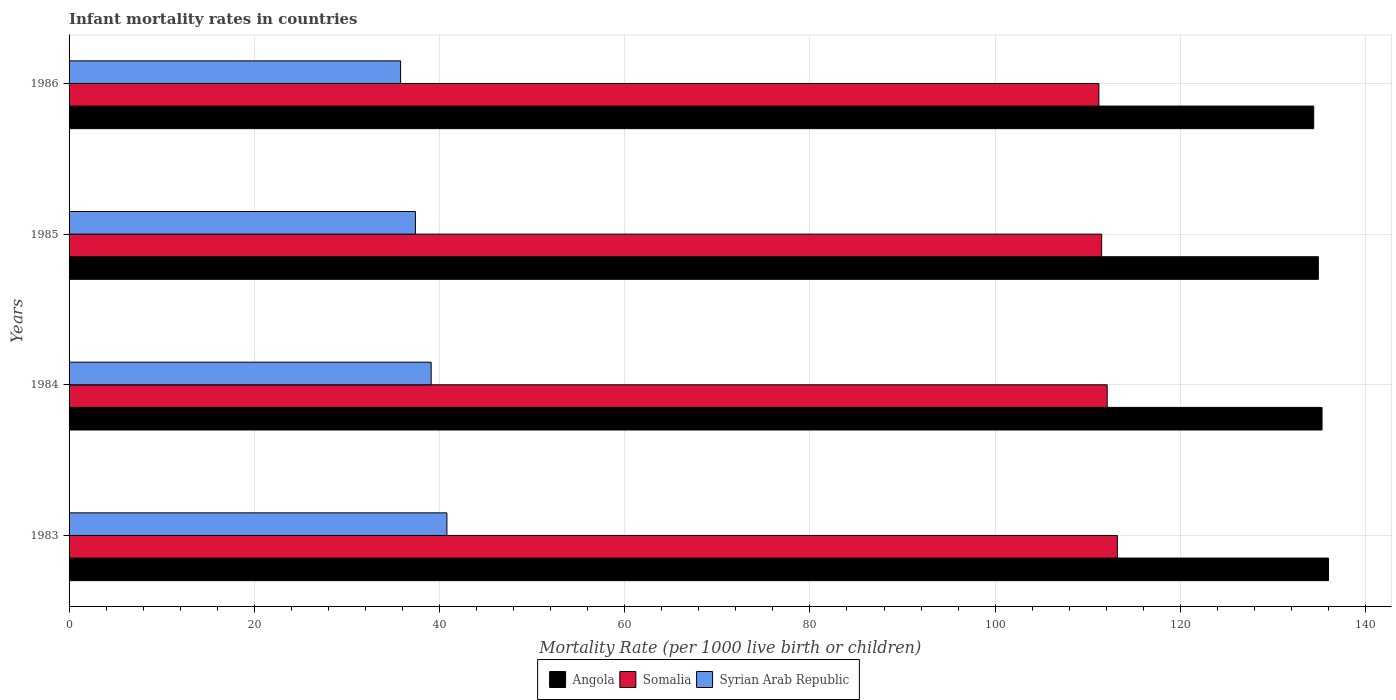How many different coloured bars are there?
Offer a terse response. 3. How many groups of bars are there?
Your answer should be very brief. 4. Are the number of bars per tick equal to the number of legend labels?
Keep it short and to the point. Yes. Are the number of bars on each tick of the Y-axis equal?
Give a very brief answer. Yes. How many bars are there on the 3rd tick from the bottom?
Ensure brevity in your answer.  3. What is the label of the 1st group of bars from the top?
Keep it short and to the point. 1986. In how many cases, is the number of bars for a given year not equal to the number of legend labels?
Provide a short and direct response. 0. What is the infant mortality rate in Syrian Arab Republic in 1986?
Your answer should be very brief. 35.8. Across all years, what is the maximum infant mortality rate in Angola?
Provide a short and direct response. 136. Across all years, what is the minimum infant mortality rate in Somalia?
Offer a very short reply. 111.2. In which year was the infant mortality rate in Somalia maximum?
Your response must be concise. 1983. In which year was the infant mortality rate in Syrian Arab Republic minimum?
Provide a short and direct response. 1986. What is the total infant mortality rate in Angola in the graph?
Provide a succinct answer. 540.6. What is the difference between the infant mortality rate in Somalia in 1983 and that in 1984?
Your answer should be very brief. 1.1. What is the difference between the infant mortality rate in Somalia in 1985 and the infant mortality rate in Syrian Arab Republic in 1983?
Make the answer very short. 70.7. What is the average infant mortality rate in Angola per year?
Offer a terse response. 135.15. In the year 1986, what is the difference between the infant mortality rate in Syrian Arab Republic and infant mortality rate in Somalia?
Ensure brevity in your answer.  -75.4. In how many years, is the infant mortality rate in Syrian Arab Republic greater than 92 ?
Make the answer very short. 0. What is the ratio of the infant mortality rate in Somalia in 1983 to that in 1986?
Your response must be concise. 1.02. Is the infant mortality rate in Somalia in 1983 less than that in 1985?
Offer a very short reply. No. Is the difference between the infant mortality rate in Syrian Arab Republic in 1983 and 1985 greater than the difference between the infant mortality rate in Somalia in 1983 and 1985?
Keep it short and to the point. Yes. What is the difference between the highest and the second highest infant mortality rate in Syrian Arab Republic?
Ensure brevity in your answer.  1.7. What is the difference between the highest and the lowest infant mortality rate in Somalia?
Ensure brevity in your answer.  2. Is the sum of the infant mortality rate in Angola in 1984 and 1986 greater than the maximum infant mortality rate in Syrian Arab Republic across all years?
Ensure brevity in your answer.  Yes. What does the 3rd bar from the top in 1986 represents?
Make the answer very short. Angola. What does the 3rd bar from the bottom in 1986 represents?
Provide a succinct answer. Syrian Arab Republic. How many bars are there?
Your response must be concise. 12. Are all the bars in the graph horizontal?
Ensure brevity in your answer.  Yes. Does the graph contain any zero values?
Your answer should be very brief. No. Does the graph contain grids?
Your response must be concise. Yes. How many legend labels are there?
Provide a succinct answer. 3. What is the title of the graph?
Provide a short and direct response. Infant mortality rates in countries. Does "Norway" appear as one of the legend labels in the graph?
Provide a succinct answer. No. What is the label or title of the X-axis?
Your response must be concise. Mortality Rate (per 1000 live birth or children). What is the Mortality Rate (per 1000 live birth or children) in Angola in 1983?
Provide a short and direct response. 136. What is the Mortality Rate (per 1000 live birth or children) in Somalia in 1983?
Offer a very short reply. 113.2. What is the Mortality Rate (per 1000 live birth or children) of Syrian Arab Republic in 1983?
Give a very brief answer. 40.8. What is the Mortality Rate (per 1000 live birth or children) of Angola in 1984?
Your answer should be compact. 135.3. What is the Mortality Rate (per 1000 live birth or children) of Somalia in 1984?
Ensure brevity in your answer.  112.1. What is the Mortality Rate (per 1000 live birth or children) of Syrian Arab Republic in 1984?
Provide a succinct answer. 39.1. What is the Mortality Rate (per 1000 live birth or children) of Angola in 1985?
Make the answer very short. 134.9. What is the Mortality Rate (per 1000 live birth or children) of Somalia in 1985?
Your response must be concise. 111.5. What is the Mortality Rate (per 1000 live birth or children) in Syrian Arab Republic in 1985?
Keep it short and to the point. 37.4. What is the Mortality Rate (per 1000 live birth or children) in Angola in 1986?
Your response must be concise. 134.4. What is the Mortality Rate (per 1000 live birth or children) in Somalia in 1986?
Provide a short and direct response. 111.2. What is the Mortality Rate (per 1000 live birth or children) in Syrian Arab Republic in 1986?
Offer a terse response. 35.8. Across all years, what is the maximum Mortality Rate (per 1000 live birth or children) in Angola?
Provide a short and direct response. 136. Across all years, what is the maximum Mortality Rate (per 1000 live birth or children) of Somalia?
Make the answer very short. 113.2. Across all years, what is the maximum Mortality Rate (per 1000 live birth or children) of Syrian Arab Republic?
Provide a succinct answer. 40.8. Across all years, what is the minimum Mortality Rate (per 1000 live birth or children) in Angola?
Your answer should be very brief. 134.4. Across all years, what is the minimum Mortality Rate (per 1000 live birth or children) in Somalia?
Your response must be concise. 111.2. Across all years, what is the minimum Mortality Rate (per 1000 live birth or children) in Syrian Arab Republic?
Offer a terse response. 35.8. What is the total Mortality Rate (per 1000 live birth or children) of Angola in the graph?
Your response must be concise. 540.6. What is the total Mortality Rate (per 1000 live birth or children) of Somalia in the graph?
Offer a very short reply. 448. What is the total Mortality Rate (per 1000 live birth or children) in Syrian Arab Republic in the graph?
Give a very brief answer. 153.1. What is the difference between the Mortality Rate (per 1000 live birth or children) in Somalia in 1983 and that in 1984?
Your answer should be very brief. 1.1. What is the difference between the Mortality Rate (per 1000 live birth or children) of Somalia in 1983 and that in 1985?
Provide a succinct answer. 1.7. What is the difference between the Mortality Rate (per 1000 live birth or children) of Angola in 1983 and that in 1986?
Provide a succinct answer. 1.6. What is the difference between the Mortality Rate (per 1000 live birth or children) in Somalia in 1983 and that in 1986?
Your answer should be compact. 2. What is the difference between the Mortality Rate (per 1000 live birth or children) of Syrian Arab Republic in 1983 and that in 1986?
Make the answer very short. 5. What is the difference between the Mortality Rate (per 1000 live birth or children) of Somalia in 1984 and that in 1986?
Offer a terse response. 0.9. What is the difference between the Mortality Rate (per 1000 live birth or children) of Syrian Arab Republic in 1984 and that in 1986?
Your response must be concise. 3.3. What is the difference between the Mortality Rate (per 1000 live birth or children) in Angola in 1985 and that in 1986?
Offer a terse response. 0.5. What is the difference between the Mortality Rate (per 1000 live birth or children) in Somalia in 1985 and that in 1986?
Keep it short and to the point. 0.3. What is the difference between the Mortality Rate (per 1000 live birth or children) in Angola in 1983 and the Mortality Rate (per 1000 live birth or children) in Somalia in 1984?
Provide a short and direct response. 23.9. What is the difference between the Mortality Rate (per 1000 live birth or children) in Angola in 1983 and the Mortality Rate (per 1000 live birth or children) in Syrian Arab Republic in 1984?
Your answer should be compact. 96.9. What is the difference between the Mortality Rate (per 1000 live birth or children) in Somalia in 1983 and the Mortality Rate (per 1000 live birth or children) in Syrian Arab Republic in 1984?
Your answer should be compact. 74.1. What is the difference between the Mortality Rate (per 1000 live birth or children) in Angola in 1983 and the Mortality Rate (per 1000 live birth or children) in Somalia in 1985?
Your answer should be very brief. 24.5. What is the difference between the Mortality Rate (per 1000 live birth or children) in Angola in 1983 and the Mortality Rate (per 1000 live birth or children) in Syrian Arab Republic in 1985?
Provide a short and direct response. 98.6. What is the difference between the Mortality Rate (per 1000 live birth or children) of Somalia in 1983 and the Mortality Rate (per 1000 live birth or children) of Syrian Arab Republic in 1985?
Offer a very short reply. 75.8. What is the difference between the Mortality Rate (per 1000 live birth or children) in Angola in 1983 and the Mortality Rate (per 1000 live birth or children) in Somalia in 1986?
Your answer should be very brief. 24.8. What is the difference between the Mortality Rate (per 1000 live birth or children) in Angola in 1983 and the Mortality Rate (per 1000 live birth or children) in Syrian Arab Republic in 1986?
Offer a terse response. 100.2. What is the difference between the Mortality Rate (per 1000 live birth or children) of Somalia in 1983 and the Mortality Rate (per 1000 live birth or children) of Syrian Arab Republic in 1986?
Give a very brief answer. 77.4. What is the difference between the Mortality Rate (per 1000 live birth or children) in Angola in 1984 and the Mortality Rate (per 1000 live birth or children) in Somalia in 1985?
Keep it short and to the point. 23.8. What is the difference between the Mortality Rate (per 1000 live birth or children) in Angola in 1984 and the Mortality Rate (per 1000 live birth or children) in Syrian Arab Republic in 1985?
Offer a very short reply. 97.9. What is the difference between the Mortality Rate (per 1000 live birth or children) in Somalia in 1984 and the Mortality Rate (per 1000 live birth or children) in Syrian Arab Republic in 1985?
Your answer should be compact. 74.7. What is the difference between the Mortality Rate (per 1000 live birth or children) of Angola in 1984 and the Mortality Rate (per 1000 live birth or children) of Somalia in 1986?
Your answer should be very brief. 24.1. What is the difference between the Mortality Rate (per 1000 live birth or children) of Angola in 1984 and the Mortality Rate (per 1000 live birth or children) of Syrian Arab Republic in 1986?
Give a very brief answer. 99.5. What is the difference between the Mortality Rate (per 1000 live birth or children) in Somalia in 1984 and the Mortality Rate (per 1000 live birth or children) in Syrian Arab Republic in 1986?
Give a very brief answer. 76.3. What is the difference between the Mortality Rate (per 1000 live birth or children) of Angola in 1985 and the Mortality Rate (per 1000 live birth or children) of Somalia in 1986?
Your answer should be compact. 23.7. What is the difference between the Mortality Rate (per 1000 live birth or children) of Angola in 1985 and the Mortality Rate (per 1000 live birth or children) of Syrian Arab Republic in 1986?
Offer a terse response. 99.1. What is the difference between the Mortality Rate (per 1000 live birth or children) in Somalia in 1985 and the Mortality Rate (per 1000 live birth or children) in Syrian Arab Republic in 1986?
Offer a very short reply. 75.7. What is the average Mortality Rate (per 1000 live birth or children) in Angola per year?
Your answer should be very brief. 135.15. What is the average Mortality Rate (per 1000 live birth or children) of Somalia per year?
Offer a very short reply. 112. What is the average Mortality Rate (per 1000 live birth or children) of Syrian Arab Republic per year?
Give a very brief answer. 38.27. In the year 1983, what is the difference between the Mortality Rate (per 1000 live birth or children) in Angola and Mortality Rate (per 1000 live birth or children) in Somalia?
Provide a short and direct response. 22.8. In the year 1983, what is the difference between the Mortality Rate (per 1000 live birth or children) in Angola and Mortality Rate (per 1000 live birth or children) in Syrian Arab Republic?
Your answer should be very brief. 95.2. In the year 1983, what is the difference between the Mortality Rate (per 1000 live birth or children) of Somalia and Mortality Rate (per 1000 live birth or children) of Syrian Arab Republic?
Ensure brevity in your answer.  72.4. In the year 1984, what is the difference between the Mortality Rate (per 1000 live birth or children) of Angola and Mortality Rate (per 1000 live birth or children) of Somalia?
Give a very brief answer. 23.2. In the year 1984, what is the difference between the Mortality Rate (per 1000 live birth or children) of Angola and Mortality Rate (per 1000 live birth or children) of Syrian Arab Republic?
Offer a very short reply. 96.2. In the year 1984, what is the difference between the Mortality Rate (per 1000 live birth or children) in Somalia and Mortality Rate (per 1000 live birth or children) in Syrian Arab Republic?
Provide a short and direct response. 73. In the year 1985, what is the difference between the Mortality Rate (per 1000 live birth or children) in Angola and Mortality Rate (per 1000 live birth or children) in Somalia?
Your answer should be very brief. 23.4. In the year 1985, what is the difference between the Mortality Rate (per 1000 live birth or children) in Angola and Mortality Rate (per 1000 live birth or children) in Syrian Arab Republic?
Provide a succinct answer. 97.5. In the year 1985, what is the difference between the Mortality Rate (per 1000 live birth or children) of Somalia and Mortality Rate (per 1000 live birth or children) of Syrian Arab Republic?
Offer a very short reply. 74.1. In the year 1986, what is the difference between the Mortality Rate (per 1000 live birth or children) of Angola and Mortality Rate (per 1000 live birth or children) of Somalia?
Your answer should be very brief. 23.2. In the year 1986, what is the difference between the Mortality Rate (per 1000 live birth or children) of Angola and Mortality Rate (per 1000 live birth or children) of Syrian Arab Republic?
Make the answer very short. 98.6. In the year 1986, what is the difference between the Mortality Rate (per 1000 live birth or children) in Somalia and Mortality Rate (per 1000 live birth or children) in Syrian Arab Republic?
Your response must be concise. 75.4. What is the ratio of the Mortality Rate (per 1000 live birth or children) of Somalia in 1983 to that in 1984?
Offer a terse response. 1.01. What is the ratio of the Mortality Rate (per 1000 live birth or children) of Syrian Arab Republic in 1983 to that in 1984?
Offer a very short reply. 1.04. What is the ratio of the Mortality Rate (per 1000 live birth or children) in Angola in 1983 to that in 1985?
Ensure brevity in your answer.  1.01. What is the ratio of the Mortality Rate (per 1000 live birth or children) of Somalia in 1983 to that in 1985?
Your answer should be compact. 1.02. What is the ratio of the Mortality Rate (per 1000 live birth or children) in Syrian Arab Republic in 1983 to that in 1985?
Offer a terse response. 1.09. What is the ratio of the Mortality Rate (per 1000 live birth or children) in Angola in 1983 to that in 1986?
Your answer should be compact. 1.01. What is the ratio of the Mortality Rate (per 1000 live birth or children) in Syrian Arab Republic in 1983 to that in 1986?
Keep it short and to the point. 1.14. What is the ratio of the Mortality Rate (per 1000 live birth or children) of Angola in 1984 to that in 1985?
Offer a very short reply. 1. What is the ratio of the Mortality Rate (per 1000 live birth or children) in Somalia in 1984 to that in 1985?
Ensure brevity in your answer.  1.01. What is the ratio of the Mortality Rate (per 1000 live birth or children) in Syrian Arab Republic in 1984 to that in 1985?
Provide a short and direct response. 1.05. What is the ratio of the Mortality Rate (per 1000 live birth or children) in Angola in 1984 to that in 1986?
Provide a succinct answer. 1.01. What is the ratio of the Mortality Rate (per 1000 live birth or children) in Syrian Arab Republic in 1984 to that in 1986?
Offer a terse response. 1.09. What is the ratio of the Mortality Rate (per 1000 live birth or children) of Angola in 1985 to that in 1986?
Offer a very short reply. 1. What is the ratio of the Mortality Rate (per 1000 live birth or children) of Syrian Arab Republic in 1985 to that in 1986?
Offer a terse response. 1.04. What is the difference between the highest and the second highest Mortality Rate (per 1000 live birth or children) of Angola?
Offer a terse response. 0.7. What is the difference between the highest and the second highest Mortality Rate (per 1000 live birth or children) in Syrian Arab Republic?
Provide a succinct answer. 1.7. What is the difference between the highest and the lowest Mortality Rate (per 1000 live birth or children) in Somalia?
Give a very brief answer. 2. What is the difference between the highest and the lowest Mortality Rate (per 1000 live birth or children) in Syrian Arab Republic?
Your answer should be very brief. 5. 